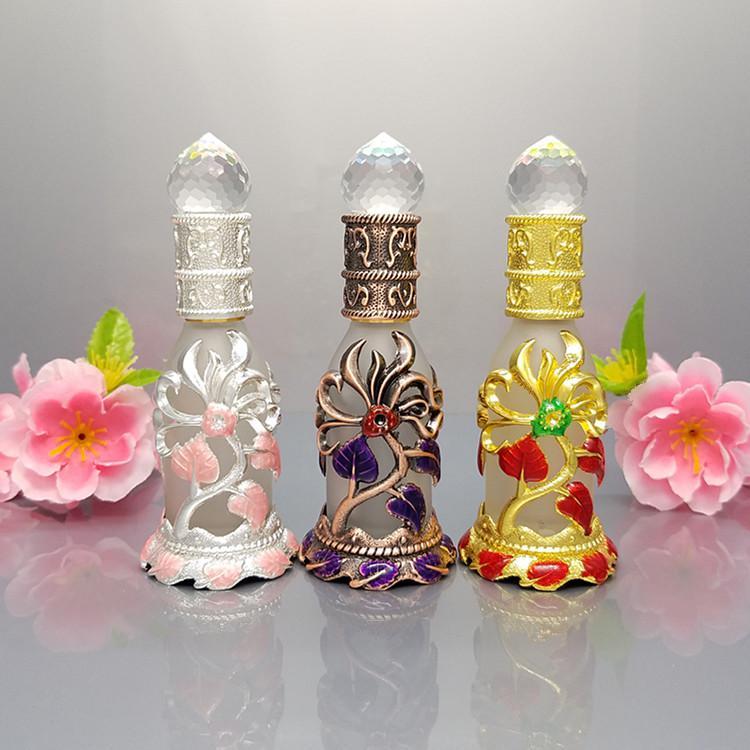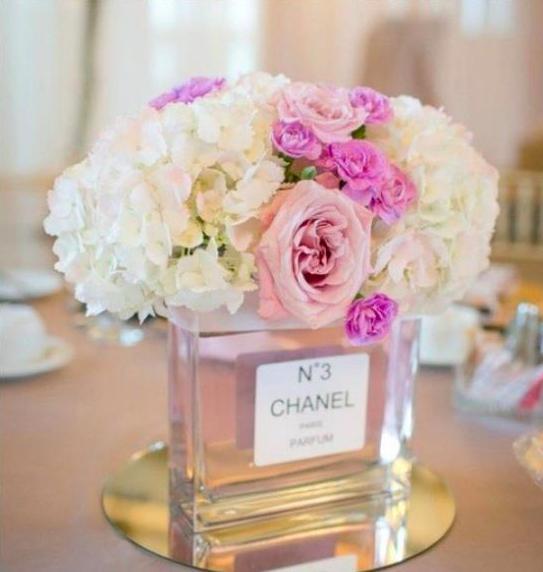The first image is the image on the left, the second image is the image on the right. For the images displayed, is the sentence "Pink flowers with green leaves flank a total of three fragrance bottles in the combined images, and at least one fragrance bottle has a clear faceted top shaped like a water drop." factually correct? Answer yes or no. Yes. The first image is the image on the left, the second image is the image on the right. Given the left and right images, does the statement "One of the images includes a string of pearls on the table." hold true? Answer yes or no. No. 